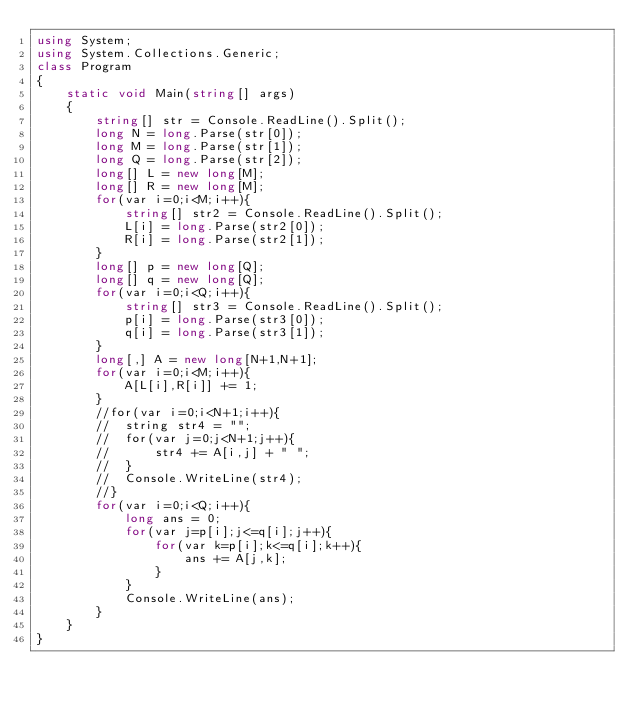<code> <loc_0><loc_0><loc_500><loc_500><_C#_>using System;
using System.Collections.Generic;
class Program
{
	static void Main(string[] args)
	{
		string[] str = Console.ReadLine().Split();
		long N = long.Parse(str[0]);
		long M = long.Parse(str[1]);
		long Q = long.Parse(str[2]);
		long[] L = new long[M];
		long[] R = new long[M];
		for(var i=0;i<M;i++){
			string[] str2 = Console.ReadLine().Split();
			L[i] = long.Parse(str2[0]);
			R[i] = long.Parse(str2[1]);
		}
		long[] p = new long[Q];
		long[] q = new long[Q];
		for(var i=0;i<Q;i++){
			string[] str3 = Console.ReadLine().Split();
			p[i] = long.Parse(str3[0]);
			q[i] = long.Parse(str3[1]);
		}
		long[,] A = new long[N+1,N+1];
		for(var i=0;i<M;i++){
			A[L[i],R[i]] += 1;
		}
		//for(var i=0;i<N+1;i++){
		//	string str4 = "";
		//	for(var j=0;j<N+1;j++){
		//		str4 += A[i,j] + " ";
		//	}
		//	Console.WriteLine(str4);
		//}
		for(var i=0;i<Q;i++){
			long ans = 0;
			for(var j=p[i];j<=q[i];j++){
				for(var k=p[i];k<=q[i];k++){
					ans += A[j,k];
				}
			}
			Console.WriteLine(ans);
		}
	}
}</code> 